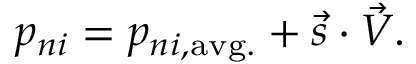<formula> <loc_0><loc_0><loc_500><loc_500>p _ { n i } = p _ { n i , a v g . } + \vec { s } \cdot \vec { V } .</formula> 